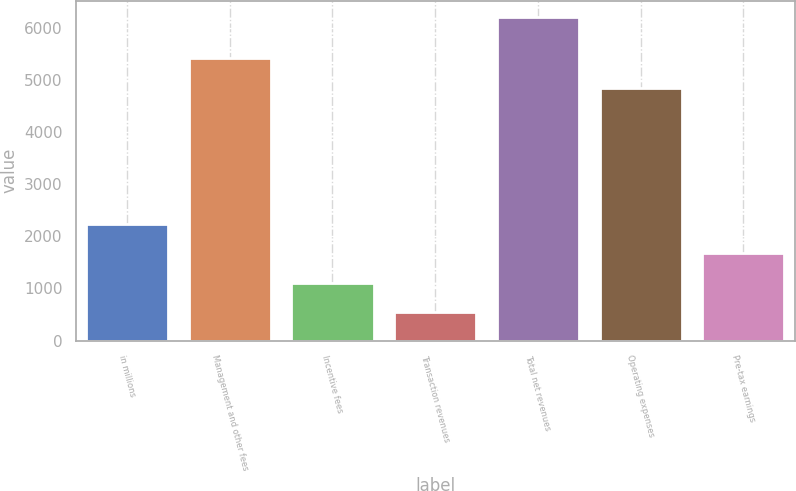Convert chart to OTSL. <chart><loc_0><loc_0><loc_500><loc_500><bar_chart><fcel>in millions<fcel>Management and other fees<fcel>Incentive fees<fcel>Transaction revenues<fcel>Total net revenues<fcel>Operating expenses<fcel>Pre-tax earnings<nl><fcel>2239.1<fcel>5407.7<fcel>1105.7<fcel>539<fcel>6206<fcel>4841<fcel>1672.4<nl></chart> 